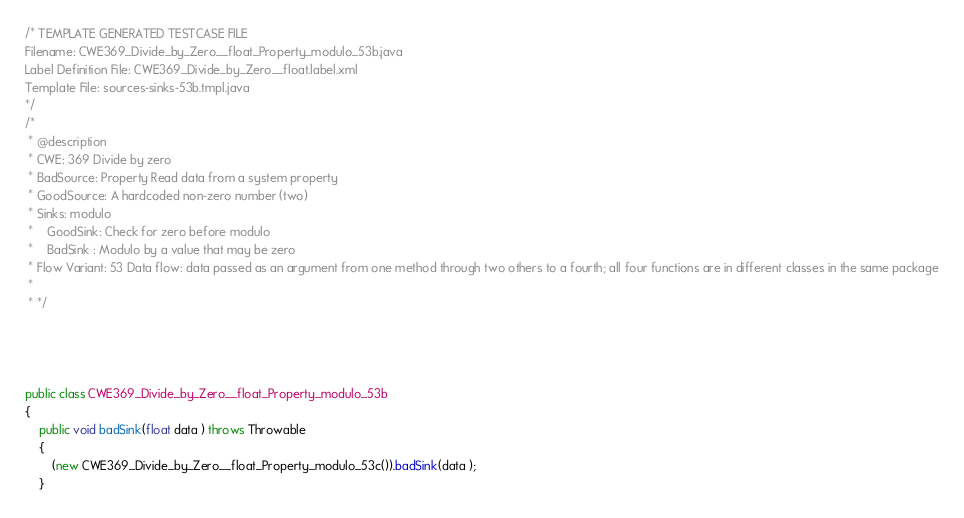<code> <loc_0><loc_0><loc_500><loc_500><_Java_>/* TEMPLATE GENERATED TESTCASE FILE
Filename: CWE369_Divide_by_Zero__float_Property_modulo_53b.java
Label Definition File: CWE369_Divide_by_Zero__float.label.xml
Template File: sources-sinks-53b.tmpl.java
*/
/*
 * @description
 * CWE: 369 Divide by zero
 * BadSource: Property Read data from a system property
 * GoodSource: A hardcoded non-zero number (two)
 * Sinks: modulo
 *    GoodSink: Check for zero before modulo
 *    BadSink : Modulo by a value that may be zero
 * Flow Variant: 53 Data flow: data passed as an argument from one method through two others to a fourth; all four functions are in different classes in the same package
 *
 * */




public class CWE369_Divide_by_Zero__float_Property_modulo_53b
{
    public void badSink(float data ) throws Throwable
    {
        (new CWE369_Divide_by_Zero__float_Property_modulo_53c()).badSink(data );
    }
</code> 